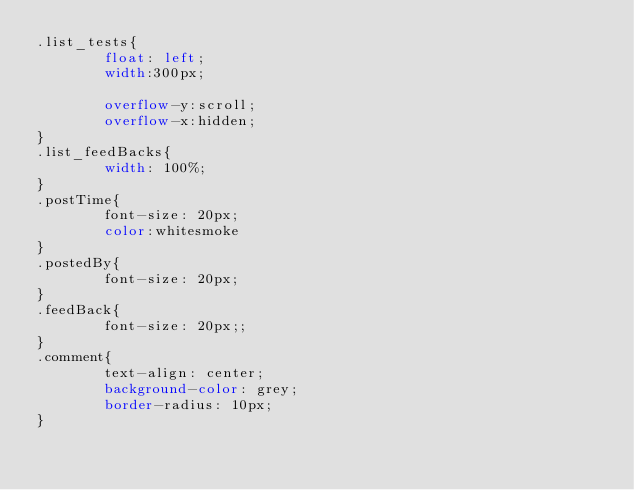<code> <loc_0><loc_0><loc_500><loc_500><_CSS_>.list_tests{
        float: left;
        width:300px;
        
        overflow-y:scroll;
        overflow-x:hidden;
}
.list_feedBacks{
        width: 100%;
}
.postTime{
        font-size: 20px;
        color:whitesmoke
}
.postedBy{
        font-size: 20px;
}
.feedBack{
        font-size: 20px;;
}
.comment{
        text-align: center;
        background-color: grey;
        border-radius: 10px;
}
</code> 